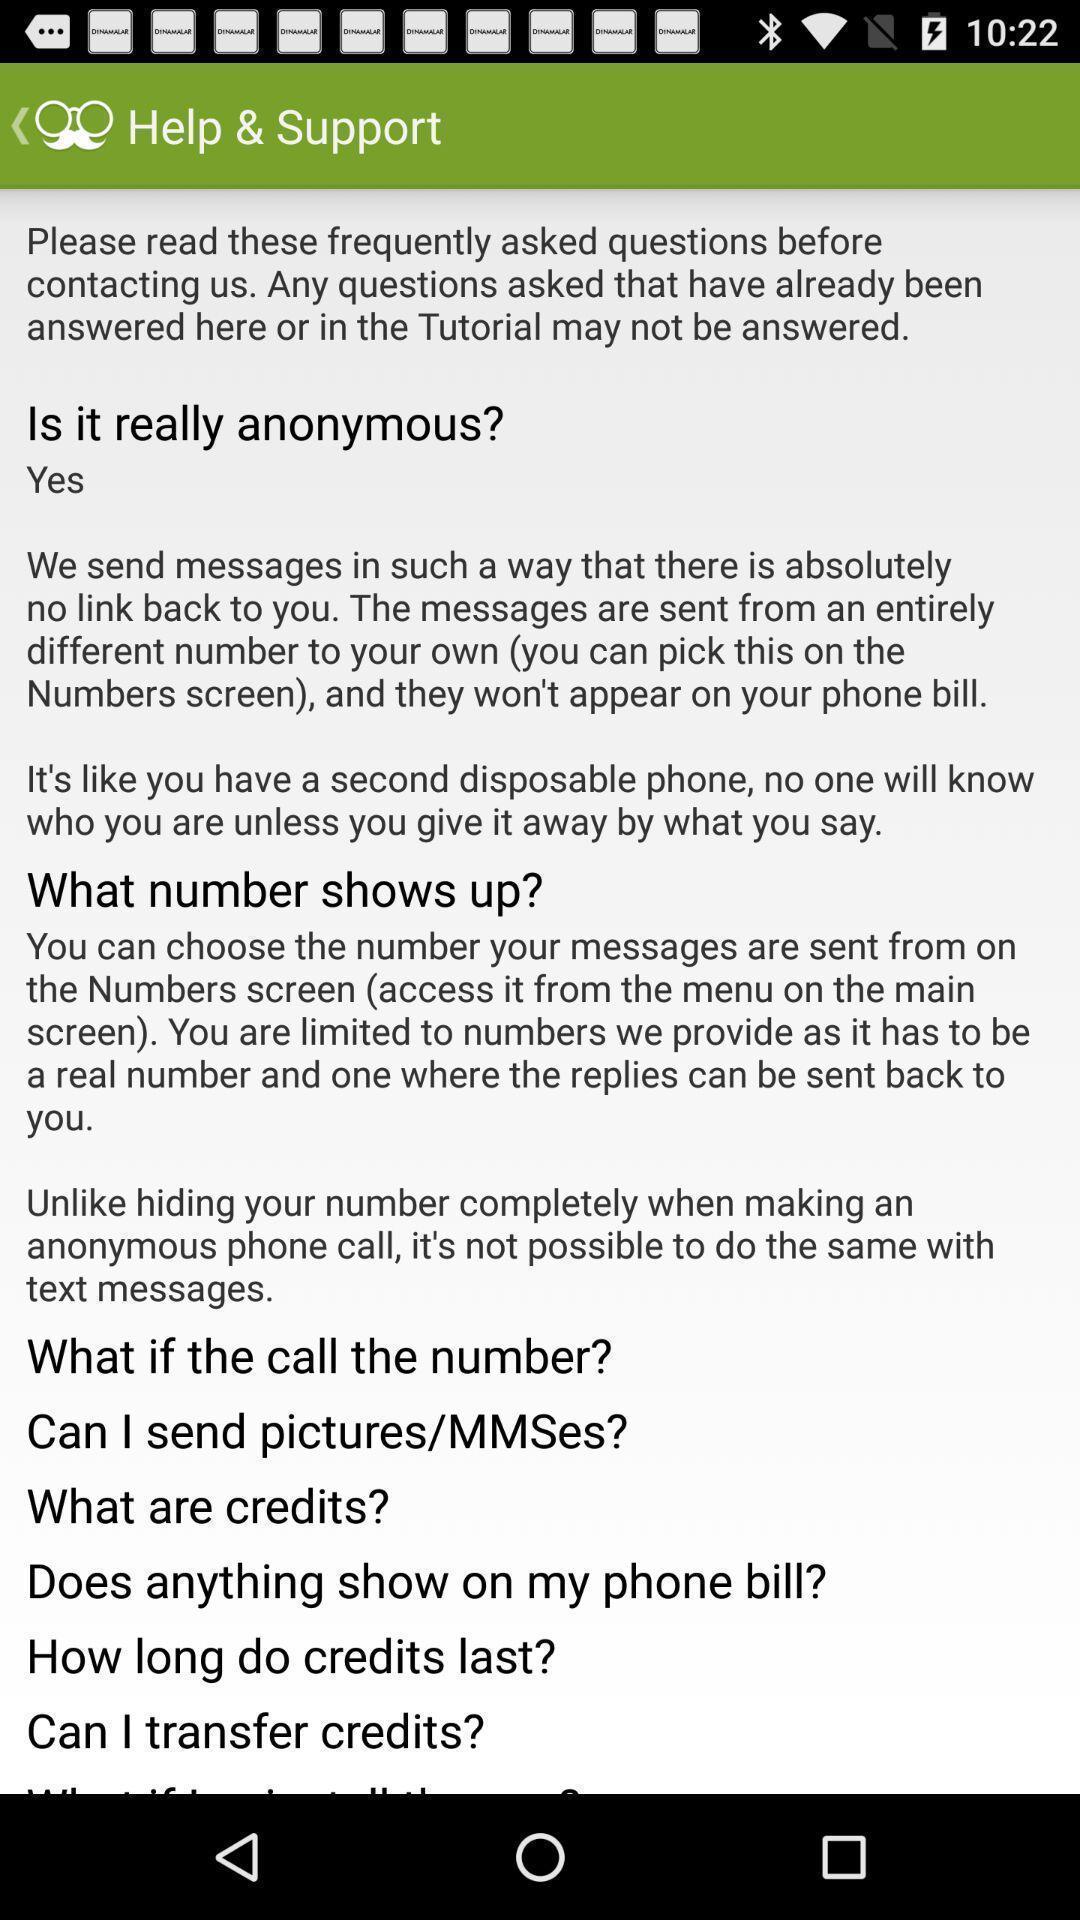Please provide a description for this image. Page shows the help support details on messaging app. 